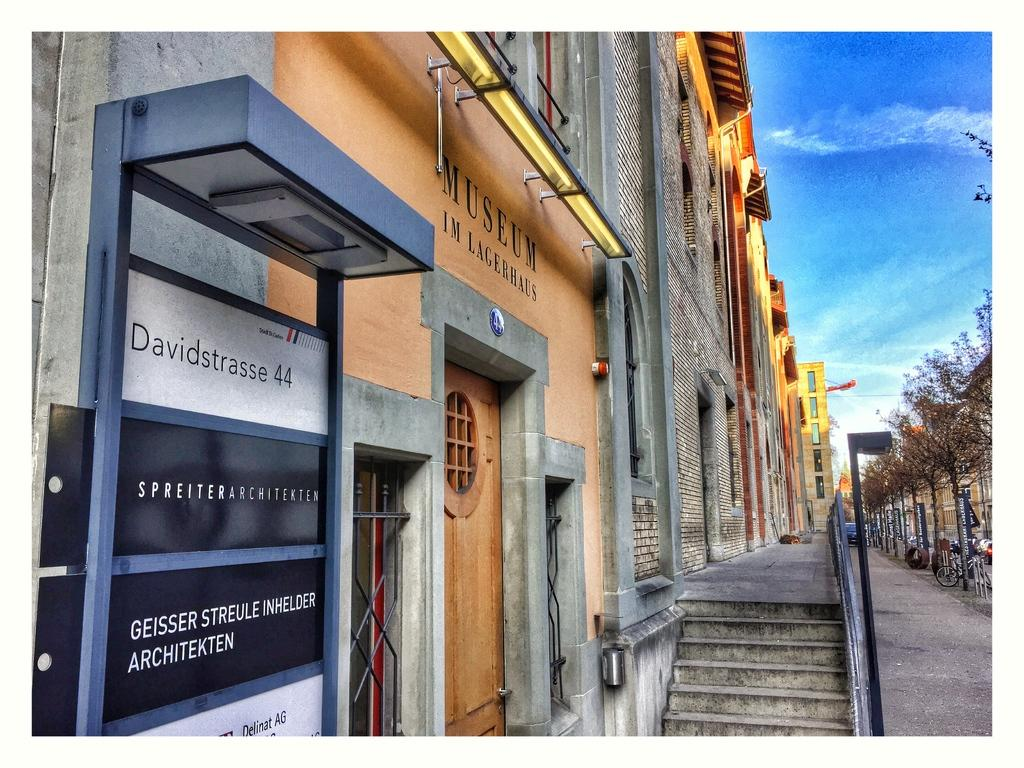What type of structures can be seen in the image? There are buildings in the image. What architectural feature is present in front of the buildings? There are stairs in front of the buildings. What other objects can be seen in the image? There are poles, trees, flags, and bicycles in the image. What is visible in the background of the image? The sky is visible in the background of the image. Can you tell me how many errors are present in the image? There are no errors present in the image; it is a clear and accurate representation of the scene. 